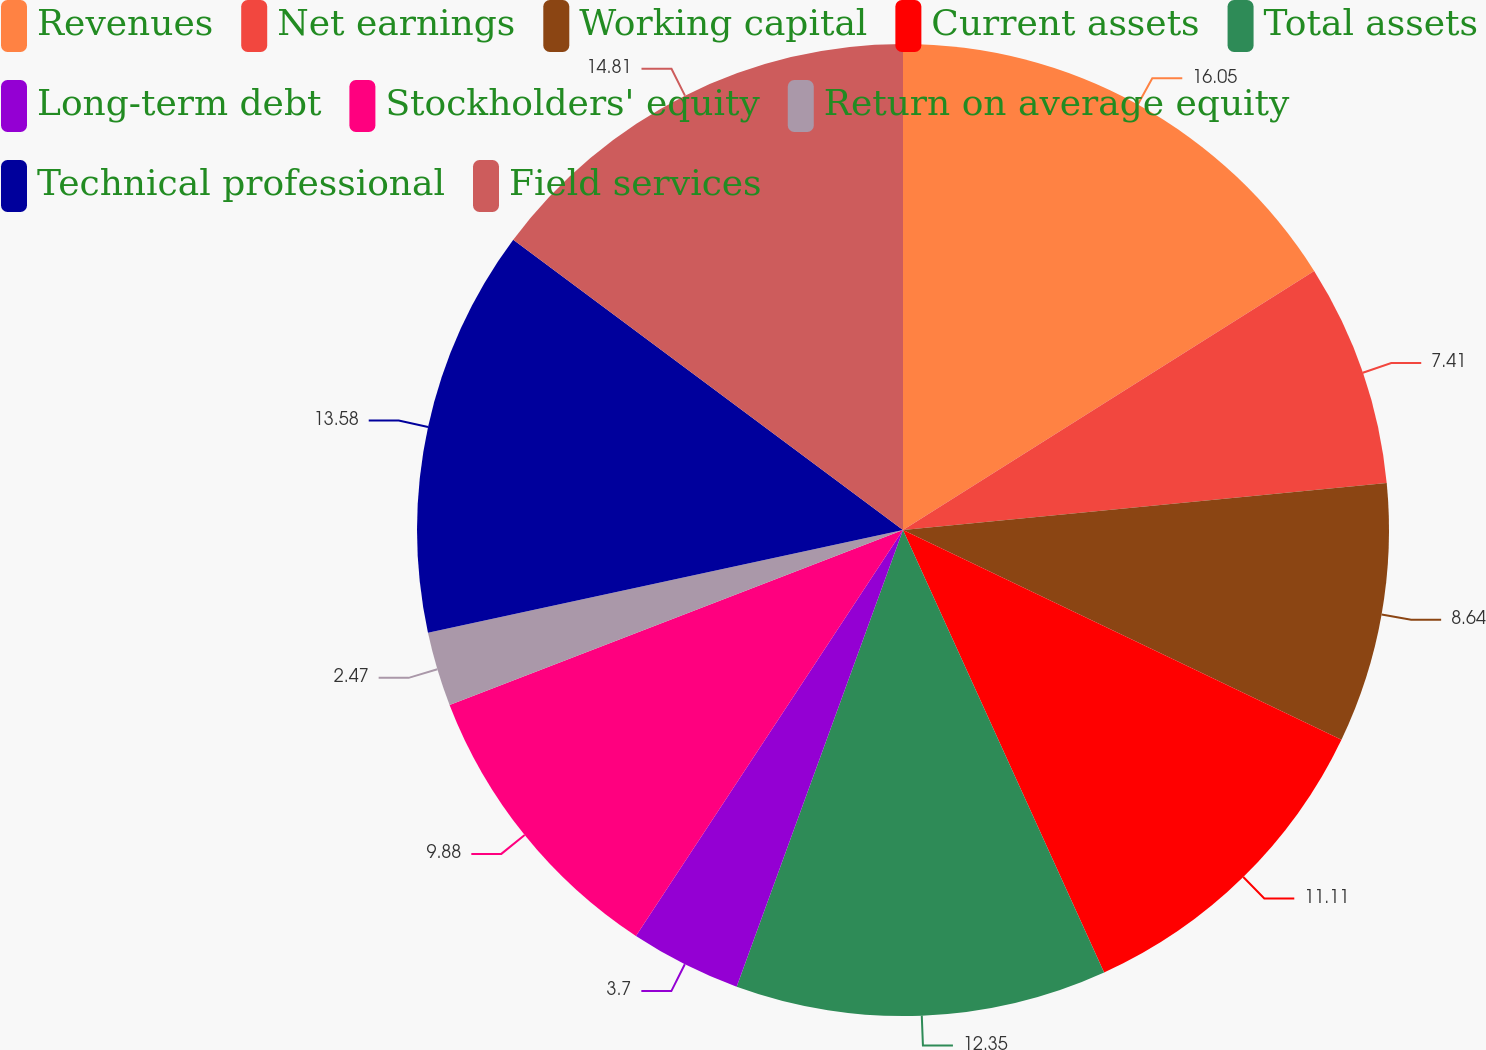Convert chart. <chart><loc_0><loc_0><loc_500><loc_500><pie_chart><fcel>Revenues<fcel>Net earnings<fcel>Working capital<fcel>Current assets<fcel>Total assets<fcel>Long-term debt<fcel>Stockholders' equity<fcel>Return on average equity<fcel>Technical professional<fcel>Field services<nl><fcel>16.05%<fcel>7.41%<fcel>8.64%<fcel>11.11%<fcel>12.35%<fcel>3.7%<fcel>9.88%<fcel>2.47%<fcel>13.58%<fcel>14.81%<nl></chart> 